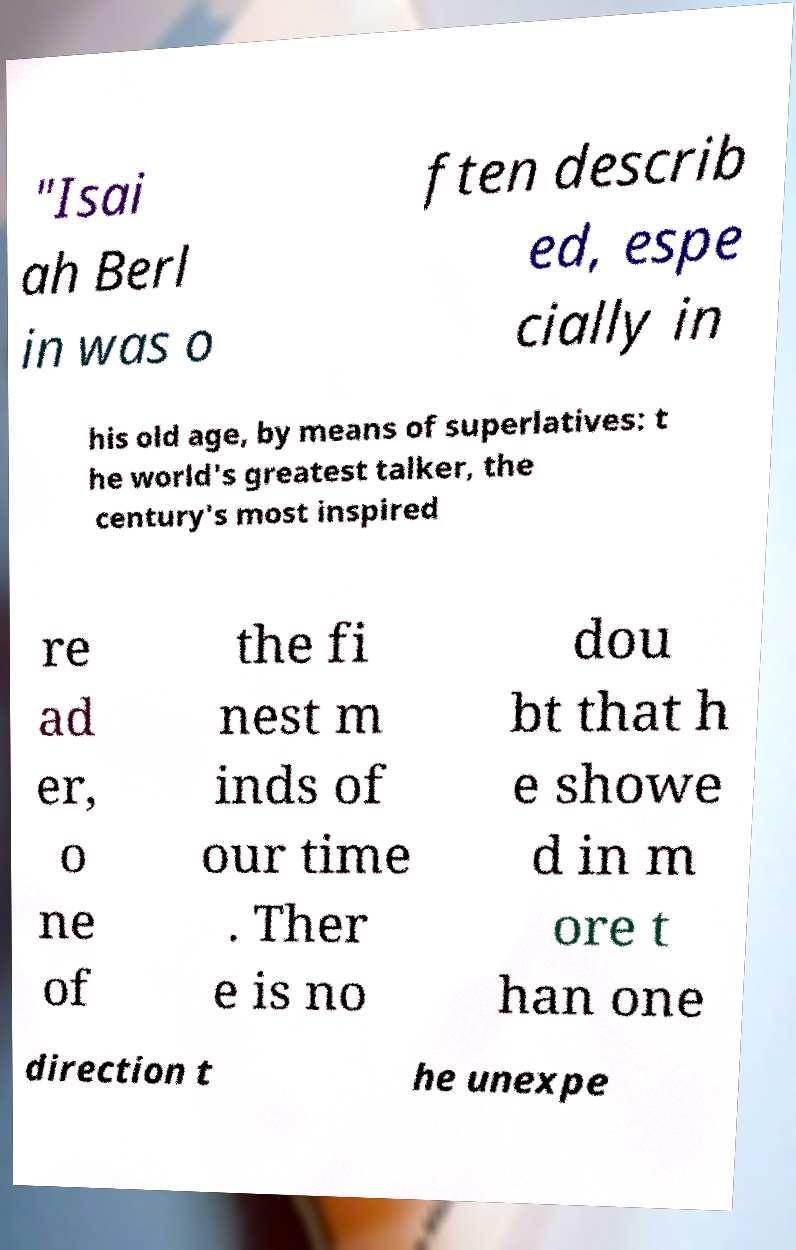Can you accurately transcribe the text from the provided image for me? "Isai ah Berl in was o ften describ ed, espe cially in his old age, by means of superlatives: t he world's greatest talker, the century's most inspired re ad er, o ne of the fi nest m inds of our time . Ther e is no dou bt that h e showe d in m ore t han one direction t he unexpe 